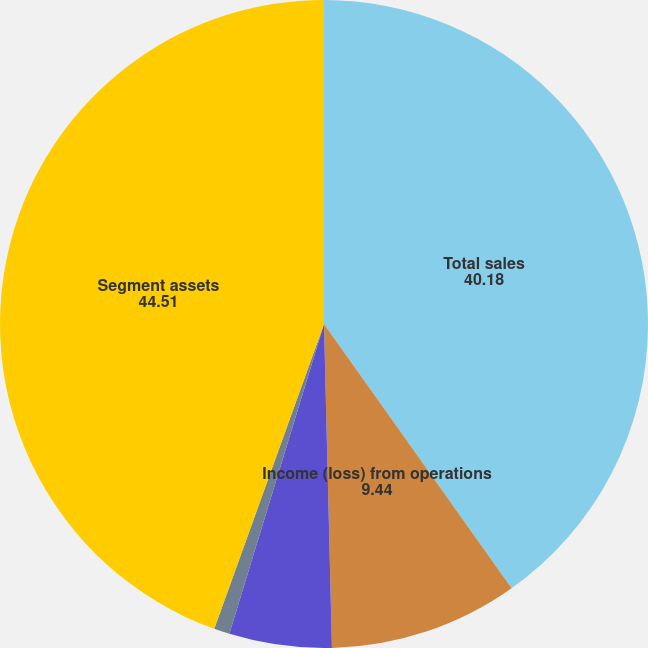<chart> <loc_0><loc_0><loc_500><loc_500><pie_chart><fcel>Total sales<fcel>Income (loss) from operations<fcel>Depreciation and amortization<fcel>Capital expenditures<fcel>Segment assets<nl><fcel>40.18%<fcel>9.44%<fcel>5.11%<fcel>0.78%<fcel>44.51%<nl></chart> 